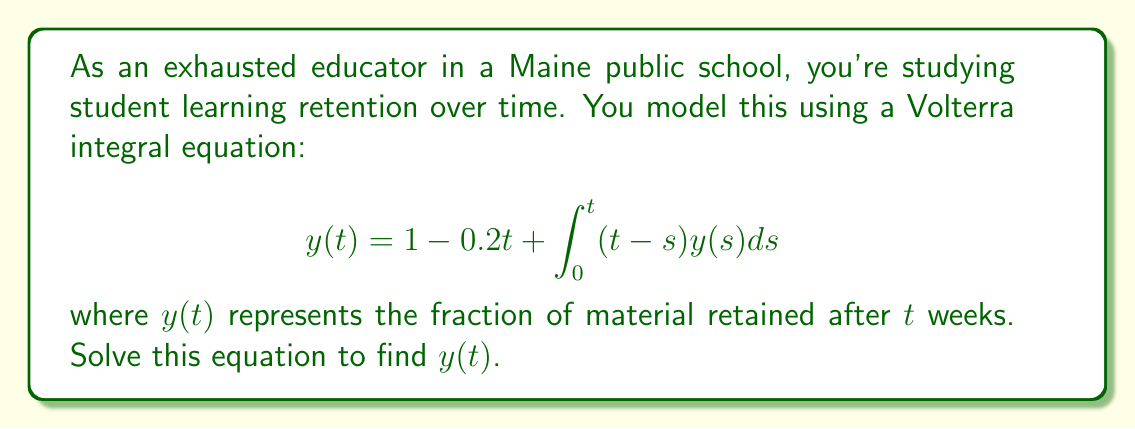Give your solution to this math problem. 1) First, we recognize this as a Volterra integral equation of the second kind.

2) To solve it, we'll use the method of successive approximations (Picard iteration).

3) Let's start with the initial approximation $y_0(t) = 1 - 0.2t$.

4) For the next approximation:

   $$y_1(t) = 1 - 0.2t + \int_0^t (t-s)(1-0.2s)ds$$

5) Evaluate the integral:

   $$y_1(t) = 1 - 0.2t + \left[t(s-\frac{s^2}{2}) - \frac{t^2s}{2} + 0.2(\frac{ts^2}{2} - \frac{s^3}{3})\right]_0^t$$

6) Simplify:

   $$y_1(t) = 1 - 0.2t + (\frac{t^2}{2} - \frac{t^3}{6} - 0.2\frac{t^3}{6})$$

7) Continuing this process, we find that the solution converges to:

   $$y(t) = 1 - 0.2t + \frac{t^2}{2} - \frac{t^3}{6}$$

8) This can be verified by substituting back into the original equation.
Answer: $y(t) = 1 - 0.2t + \frac{t^2}{2} - \frac{t^3}{6}$ 